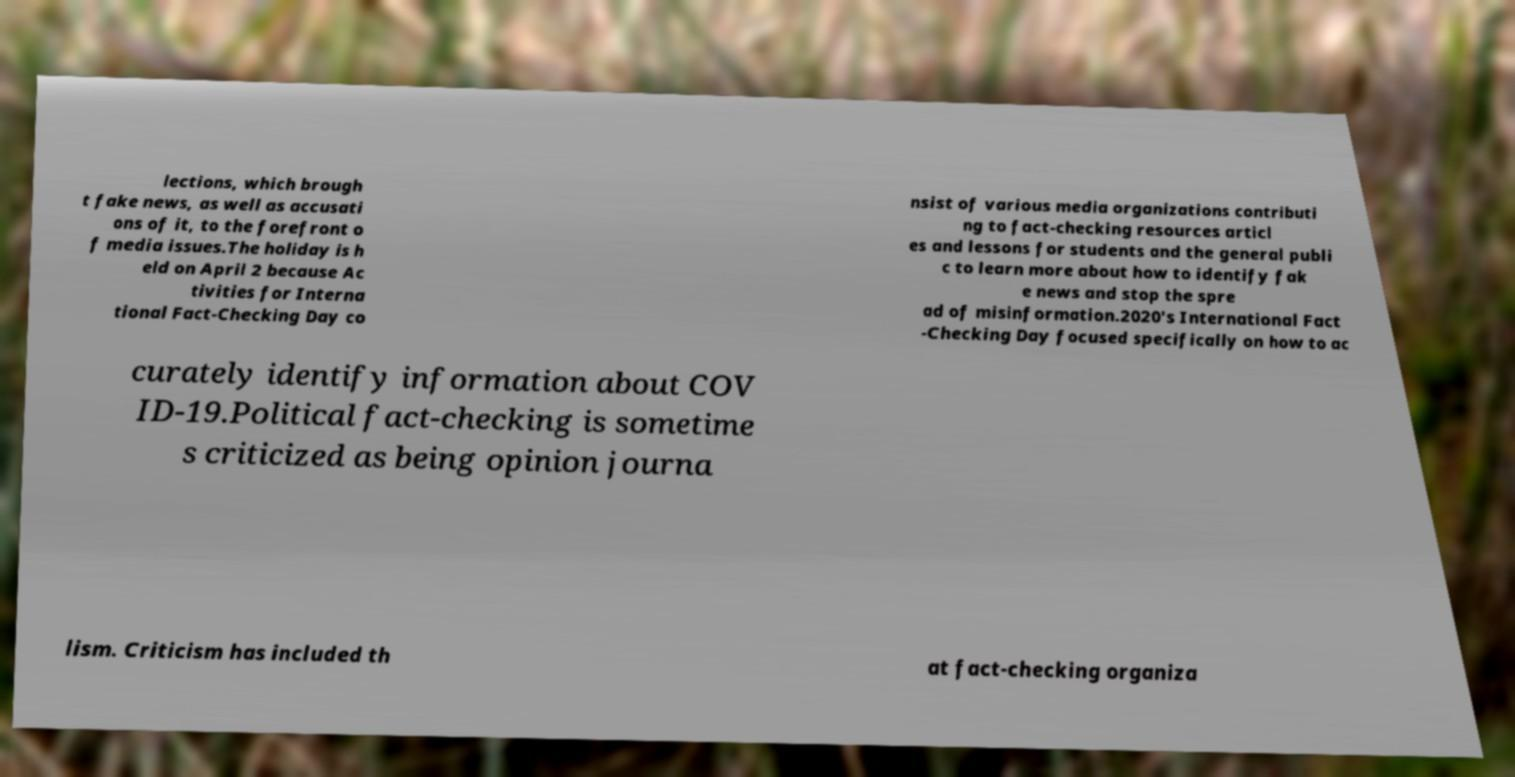What messages or text are displayed in this image? I need them in a readable, typed format. lections, which brough t fake news, as well as accusati ons of it, to the forefront o f media issues.The holiday is h eld on April 2 because Ac tivities for Interna tional Fact-Checking Day co nsist of various media organizations contributi ng to fact-checking resources articl es and lessons for students and the general publi c to learn more about how to identify fak e news and stop the spre ad of misinformation.2020's International Fact -Checking Day focused specifically on how to ac curately identify information about COV ID-19.Political fact-checking is sometime s criticized as being opinion journa lism. Criticism has included th at fact-checking organiza 